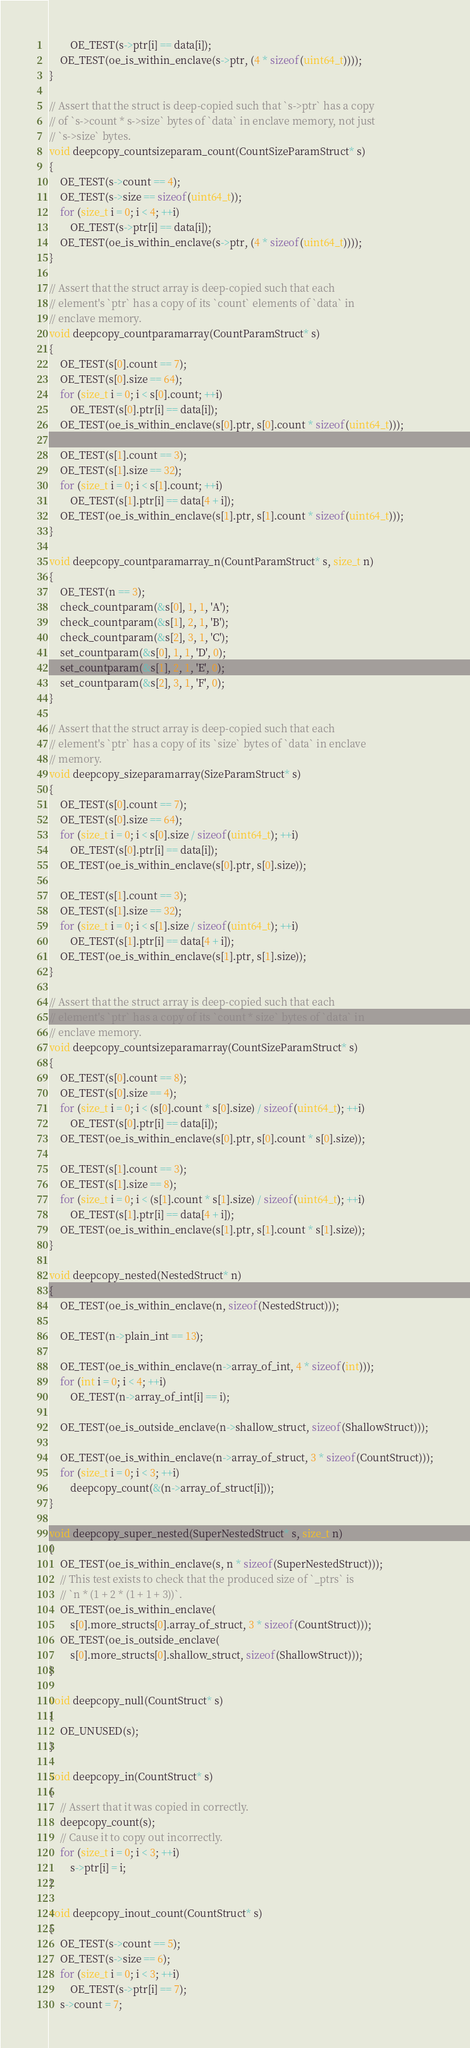<code> <loc_0><loc_0><loc_500><loc_500><_C++_>        OE_TEST(s->ptr[i] == data[i]);
    OE_TEST(oe_is_within_enclave(s->ptr, (4 * sizeof(uint64_t))));
}

// Assert that the struct is deep-copied such that `s->ptr` has a copy
// of `s->count * s->size` bytes of `data` in enclave memory, not just
// `s->size` bytes.
void deepcopy_countsizeparam_count(CountSizeParamStruct* s)
{
    OE_TEST(s->count == 4);
    OE_TEST(s->size == sizeof(uint64_t));
    for (size_t i = 0; i < 4; ++i)
        OE_TEST(s->ptr[i] == data[i]);
    OE_TEST(oe_is_within_enclave(s->ptr, (4 * sizeof(uint64_t))));
}

// Assert that the struct array is deep-copied such that each
// element's `ptr` has a copy of its `count` elements of `data` in
// enclave memory.
void deepcopy_countparamarray(CountParamStruct* s)
{
    OE_TEST(s[0].count == 7);
    OE_TEST(s[0].size == 64);
    for (size_t i = 0; i < s[0].count; ++i)
        OE_TEST(s[0].ptr[i] == data[i]);
    OE_TEST(oe_is_within_enclave(s[0].ptr, s[0].count * sizeof(uint64_t)));

    OE_TEST(s[1].count == 3);
    OE_TEST(s[1].size == 32);
    for (size_t i = 0; i < s[1].count; ++i)
        OE_TEST(s[1].ptr[i] == data[4 + i]);
    OE_TEST(oe_is_within_enclave(s[1].ptr, s[1].count * sizeof(uint64_t)));
}

void deepcopy_countparamarray_n(CountParamStruct* s, size_t n)
{
    OE_TEST(n == 3);
    check_countparam(&s[0], 1, 1, 'A');
    check_countparam(&s[1], 2, 1, 'B');
    check_countparam(&s[2], 3, 1, 'C');
    set_countparam(&s[0], 1, 1, 'D', 0);
    set_countparam(&s[1], 2, 1, 'E', 0);
    set_countparam(&s[2], 3, 1, 'F', 0);
}

// Assert that the struct array is deep-copied such that each
// element's `ptr` has a copy of its `size` bytes of `data` in enclave
// memory.
void deepcopy_sizeparamarray(SizeParamStruct* s)
{
    OE_TEST(s[0].count == 7);
    OE_TEST(s[0].size == 64);
    for (size_t i = 0; i < s[0].size / sizeof(uint64_t); ++i)
        OE_TEST(s[0].ptr[i] == data[i]);
    OE_TEST(oe_is_within_enclave(s[0].ptr, s[0].size));

    OE_TEST(s[1].count == 3);
    OE_TEST(s[1].size == 32);
    for (size_t i = 0; i < s[1].size / sizeof(uint64_t); ++i)
        OE_TEST(s[1].ptr[i] == data[4 + i]);
    OE_TEST(oe_is_within_enclave(s[1].ptr, s[1].size));
}

// Assert that the struct array is deep-copied such that each
// element's `ptr` has a copy of its `count * size` bytes of `data` in
// enclave memory.
void deepcopy_countsizeparamarray(CountSizeParamStruct* s)
{
    OE_TEST(s[0].count == 8);
    OE_TEST(s[0].size == 4);
    for (size_t i = 0; i < (s[0].count * s[0].size) / sizeof(uint64_t); ++i)
        OE_TEST(s[0].ptr[i] == data[i]);
    OE_TEST(oe_is_within_enclave(s[0].ptr, s[0].count * s[0].size));

    OE_TEST(s[1].count == 3);
    OE_TEST(s[1].size == 8);
    for (size_t i = 0; i < (s[1].count * s[1].size) / sizeof(uint64_t); ++i)
        OE_TEST(s[1].ptr[i] == data[4 + i]);
    OE_TEST(oe_is_within_enclave(s[1].ptr, s[1].count * s[1].size));
}

void deepcopy_nested(NestedStruct* n)
{
    OE_TEST(oe_is_within_enclave(n, sizeof(NestedStruct)));

    OE_TEST(n->plain_int == 13);

    OE_TEST(oe_is_within_enclave(n->array_of_int, 4 * sizeof(int)));
    for (int i = 0; i < 4; ++i)
        OE_TEST(n->array_of_int[i] == i);

    OE_TEST(oe_is_outside_enclave(n->shallow_struct, sizeof(ShallowStruct)));

    OE_TEST(oe_is_within_enclave(n->array_of_struct, 3 * sizeof(CountStruct)));
    for (size_t i = 0; i < 3; ++i)
        deepcopy_count(&(n->array_of_struct[i]));
}

void deepcopy_super_nested(SuperNestedStruct* s, size_t n)
{
    OE_TEST(oe_is_within_enclave(s, n * sizeof(SuperNestedStruct)));
    // This test exists to check that the produced size of `_ptrs` is
    // `n * (1 + 2 * (1 + 1 + 3))`.
    OE_TEST(oe_is_within_enclave(
        s[0].more_structs[0].array_of_struct, 3 * sizeof(CountStruct)));
    OE_TEST(oe_is_outside_enclave(
        s[0].more_structs[0].shallow_struct, sizeof(ShallowStruct)));
}

void deepcopy_null(CountStruct* s)
{
    OE_UNUSED(s);
}

void deepcopy_in(CountStruct* s)
{
    // Assert that it was copied in correctly.
    deepcopy_count(s);
    // Cause it to copy out incorrectly.
    for (size_t i = 0; i < 3; ++i)
        s->ptr[i] = i;
}

void deepcopy_inout_count(CountStruct* s)
{
    OE_TEST(s->count == 5);
    OE_TEST(s->size == 6);
    for (size_t i = 0; i < 3; ++i)
        OE_TEST(s->ptr[i] == 7);
    s->count = 7;</code> 